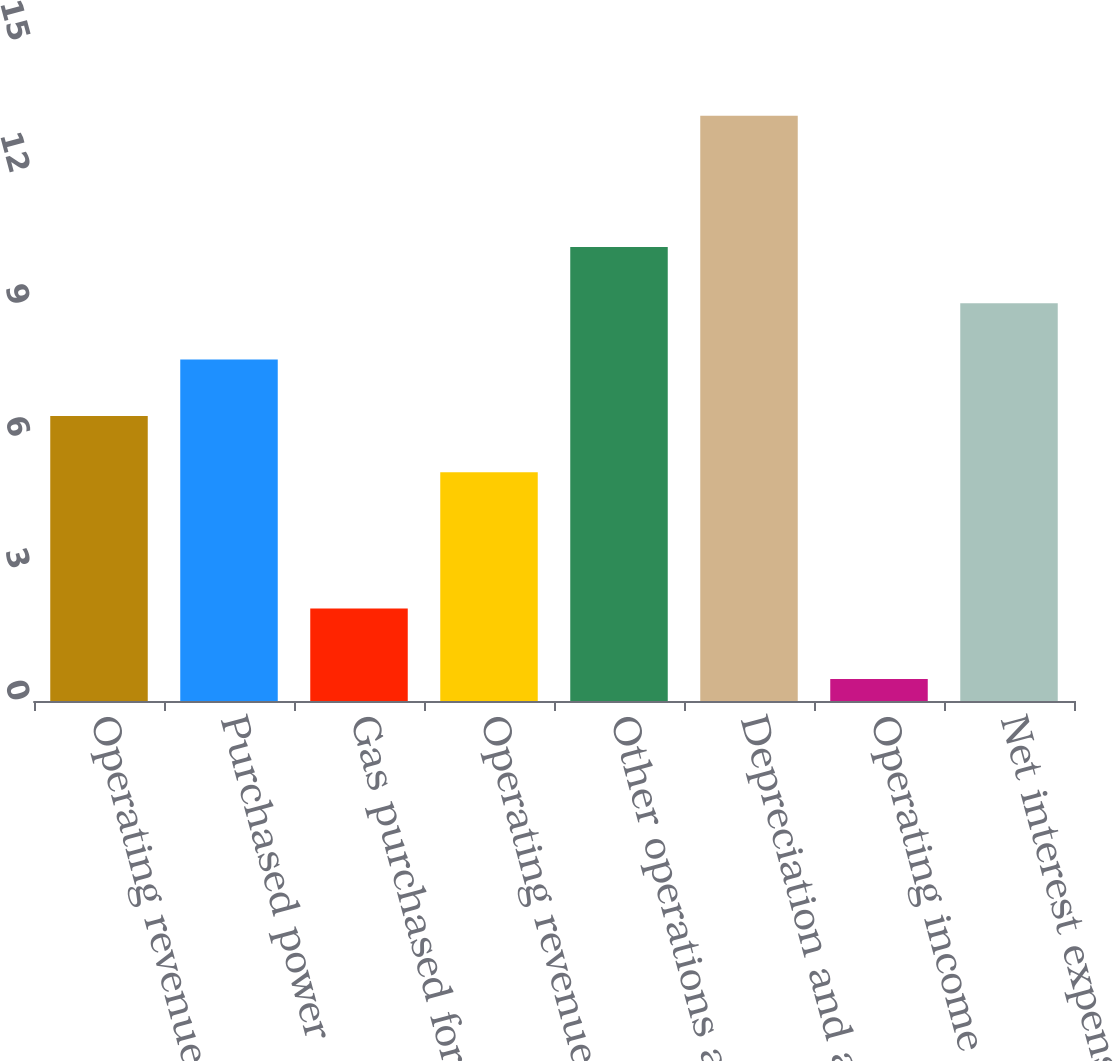<chart> <loc_0><loc_0><loc_500><loc_500><bar_chart><fcel>Operating revenues<fcel>Purchased power<fcel>Gas purchased for resale<fcel>Operating revenues less<fcel>Other operations and<fcel>Depreciation and amortization<fcel>Operating income<fcel>Net interest expense<nl><fcel>6.48<fcel>7.76<fcel>2.1<fcel>5.2<fcel>10.32<fcel>13.3<fcel>0.5<fcel>9.04<nl></chart> 